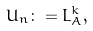<formula> <loc_0><loc_0><loc_500><loc_500>U _ { n } \colon = L ^ { k } _ { A } ,</formula> 